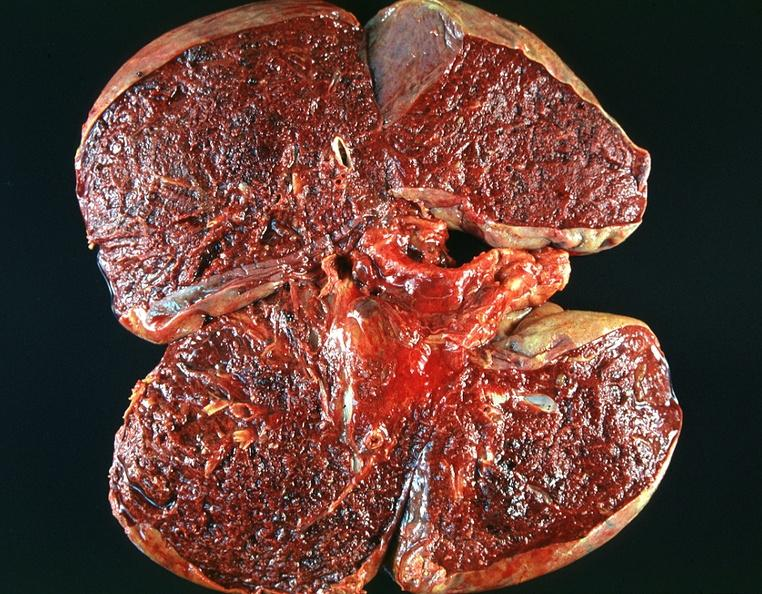what does this image show?
Answer the question using a single word or phrase. Lung 